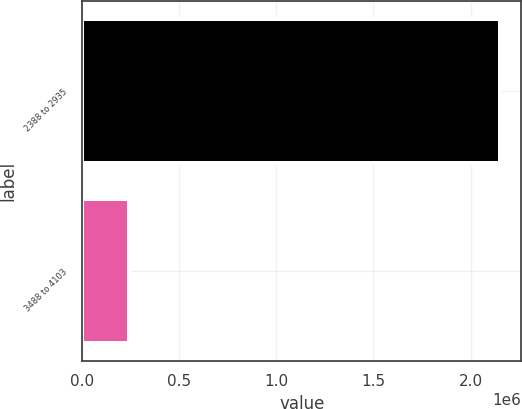Convert chart. <chart><loc_0><loc_0><loc_500><loc_500><bar_chart><fcel>2388 to 2935<fcel>3488 to 4103<nl><fcel>2.15351e+06<fcel>238755<nl></chart> 